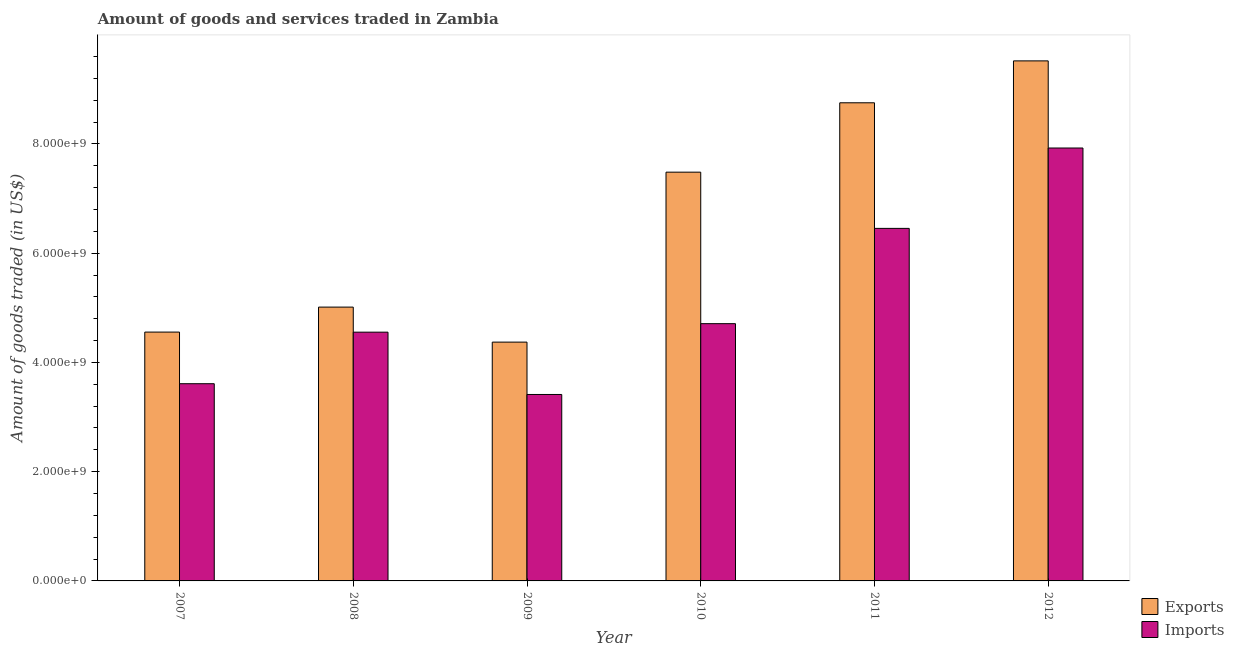How many groups of bars are there?
Make the answer very short. 6. How many bars are there on the 5th tick from the left?
Provide a short and direct response. 2. What is the label of the 4th group of bars from the left?
Your answer should be compact. 2010. In how many cases, is the number of bars for a given year not equal to the number of legend labels?
Offer a terse response. 0. What is the amount of goods exported in 2012?
Keep it short and to the point. 9.52e+09. Across all years, what is the maximum amount of goods exported?
Offer a very short reply. 9.52e+09. Across all years, what is the minimum amount of goods imported?
Your answer should be compact. 3.41e+09. In which year was the amount of goods exported maximum?
Provide a short and direct response. 2012. What is the total amount of goods imported in the graph?
Give a very brief answer. 3.07e+1. What is the difference between the amount of goods imported in 2007 and that in 2010?
Make the answer very short. -1.10e+09. What is the difference between the amount of goods exported in 2011 and the amount of goods imported in 2010?
Provide a succinct answer. 1.27e+09. What is the average amount of goods exported per year?
Your answer should be very brief. 6.62e+09. What is the ratio of the amount of goods imported in 2009 to that in 2010?
Your answer should be compact. 0.72. What is the difference between the highest and the second highest amount of goods imported?
Your response must be concise. 1.47e+09. What is the difference between the highest and the lowest amount of goods imported?
Keep it short and to the point. 4.51e+09. In how many years, is the amount of goods exported greater than the average amount of goods exported taken over all years?
Ensure brevity in your answer.  3. What does the 2nd bar from the left in 2009 represents?
Keep it short and to the point. Imports. What does the 1st bar from the right in 2010 represents?
Offer a very short reply. Imports. How many bars are there?
Keep it short and to the point. 12. Are all the bars in the graph horizontal?
Provide a short and direct response. No. Does the graph contain grids?
Your answer should be compact. No. How many legend labels are there?
Your answer should be compact. 2. What is the title of the graph?
Your response must be concise. Amount of goods and services traded in Zambia. Does "Urban" appear as one of the legend labels in the graph?
Provide a succinct answer. No. What is the label or title of the Y-axis?
Make the answer very short. Amount of goods traded (in US$). What is the Amount of goods traded (in US$) in Exports in 2007?
Ensure brevity in your answer.  4.56e+09. What is the Amount of goods traded (in US$) in Imports in 2007?
Provide a short and direct response. 3.61e+09. What is the Amount of goods traded (in US$) in Exports in 2008?
Your answer should be compact. 5.01e+09. What is the Amount of goods traded (in US$) in Imports in 2008?
Offer a terse response. 4.55e+09. What is the Amount of goods traded (in US$) of Exports in 2009?
Offer a terse response. 4.37e+09. What is the Amount of goods traded (in US$) in Imports in 2009?
Keep it short and to the point. 3.41e+09. What is the Amount of goods traded (in US$) in Exports in 2010?
Offer a terse response. 7.48e+09. What is the Amount of goods traded (in US$) in Imports in 2010?
Offer a terse response. 4.71e+09. What is the Amount of goods traded (in US$) of Exports in 2011?
Your answer should be compact. 8.75e+09. What is the Amount of goods traded (in US$) of Imports in 2011?
Provide a succinct answer. 6.45e+09. What is the Amount of goods traded (in US$) of Exports in 2012?
Give a very brief answer. 9.52e+09. What is the Amount of goods traded (in US$) in Imports in 2012?
Provide a short and direct response. 7.93e+09. Across all years, what is the maximum Amount of goods traded (in US$) in Exports?
Provide a short and direct response. 9.52e+09. Across all years, what is the maximum Amount of goods traded (in US$) of Imports?
Offer a terse response. 7.93e+09. Across all years, what is the minimum Amount of goods traded (in US$) of Exports?
Your answer should be compact. 4.37e+09. Across all years, what is the minimum Amount of goods traded (in US$) of Imports?
Your answer should be very brief. 3.41e+09. What is the total Amount of goods traded (in US$) in Exports in the graph?
Ensure brevity in your answer.  3.97e+1. What is the total Amount of goods traded (in US$) of Imports in the graph?
Offer a very short reply. 3.07e+1. What is the difference between the Amount of goods traded (in US$) of Exports in 2007 and that in 2008?
Provide a succinct answer. -4.58e+08. What is the difference between the Amount of goods traded (in US$) in Imports in 2007 and that in 2008?
Your answer should be very brief. -9.44e+08. What is the difference between the Amount of goods traded (in US$) of Exports in 2007 and that in 2009?
Keep it short and to the point. 1.84e+08. What is the difference between the Amount of goods traded (in US$) of Imports in 2007 and that in 2009?
Offer a terse response. 1.97e+08. What is the difference between the Amount of goods traded (in US$) in Exports in 2007 and that in 2010?
Provide a short and direct response. -2.93e+09. What is the difference between the Amount of goods traded (in US$) in Imports in 2007 and that in 2010?
Your answer should be compact. -1.10e+09. What is the difference between the Amount of goods traded (in US$) of Exports in 2007 and that in 2011?
Keep it short and to the point. -4.20e+09. What is the difference between the Amount of goods traded (in US$) of Imports in 2007 and that in 2011?
Your answer should be very brief. -2.84e+09. What is the difference between the Amount of goods traded (in US$) of Exports in 2007 and that in 2012?
Your response must be concise. -4.97e+09. What is the difference between the Amount of goods traded (in US$) in Imports in 2007 and that in 2012?
Offer a terse response. -4.31e+09. What is the difference between the Amount of goods traded (in US$) in Exports in 2008 and that in 2009?
Offer a terse response. 6.41e+08. What is the difference between the Amount of goods traded (in US$) in Imports in 2008 and that in 2009?
Give a very brief answer. 1.14e+09. What is the difference between the Amount of goods traded (in US$) in Exports in 2008 and that in 2010?
Make the answer very short. -2.47e+09. What is the difference between the Amount of goods traded (in US$) in Imports in 2008 and that in 2010?
Give a very brief answer. -1.56e+08. What is the difference between the Amount of goods traded (in US$) in Exports in 2008 and that in 2011?
Your answer should be very brief. -3.74e+09. What is the difference between the Amount of goods traded (in US$) of Imports in 2008 and that in 2011?
Offer a very short reply. -1.90e+09. What is the difference between the Amount of goods traded (in US$) of Exports in 2008 and that in 2012?
Your answer should be very brief. -4.51e+09. What is the difference between the Amount of goods traded (in US$) of Imports in 2008 and that in 2012?
Provide a short and direct response. -3.37e+09. What is the difference between the Amount of goods traded (in US$) in Exports in 2009 and that in 2010?
Your answer should be very brief. -3.11e+09. What is the difference between the Amount of goods traded (in US$) in Imports in 2009 and that in 2010?
Provide a succinct answer. -1.30e+09. What is the difference between the Amount of goods traded (in US$) of Exports in 2009 and that in 2011?
Offer a very short reply. -4.38e+09. What is the difference between the Amount of goods traded (in US$) of Imports in 2009 and that in 2011?
Your answer should be very brief. -3.04e+09. What is the difference between the Amount of goods traded (in US$) in Exports in 2009 and that in 2012?
Provide a short and direct response. -5.15e+09. What is the difference between the Amount of goods traded (in US$) of Imports in 2009 and that in 2012?
Offer a terse response. -4.51e+09. What is the difference between the Amount of goods traded (in US$) of Exports in 2010 and that in 2011?
Provide a short and direct response. -1.27e+09. What is the difference between the Amount of goods traded (in US$) in Imports in 2010 and that in 2011?
Your answer should be very brief. -1.74e+09. What is the difference between the Amount of goods traded (in US$) in Exports in 2010 and that in 2012?
Ensure brevity in your answer.  -2.04e+09. What is the difference between the Amount of goods traded (in US$) of Imports in 2010 and that in 2012?
Keep it short and to the point. -3.22e+09. What is the difference between the Amount of goods traded (in US$) of Exports in 2011 and that in 2012?
Offer a terse response. -7.67e+08. What is the difference between the Amount of goods traded (in US$) of Imports in 2011 and that in 2012?
Make the answer very short. -1.47e+09. What is the difference between the Amount of goods traded (in US$) in Exports in 2007 and the Amount of goods traded (in US$) in Imports in 2008?
Your answer should be very brief. 1.37e+06. What is the difference between the Amount of goods traded (in US$) of Exports in 2007 and the Amount of goods traded (in US$) of Imports in 2009?
Ensure brevity in your answer.  1.14e+09. What is the difference between the Amount of goods traded (in US$) of Exports in 2007 and the Amount of goods traded (in US$) of Imports in 2010?
Give a very brief answer. -1.54e+08. What is the difference between the Amount of goods traded (in US$) of Exports in 2007 and the Amount of goods traded (in US$) of Imports in 2011?
Provide a succinct answer. -1.90e+09. What is the difference between the Amount of goods traded (in US$) of Exports in 2007 and the Amount of goods traded (in US$) of Imports in 2012?
Your answer should be compact. -3.37e+09. What is the difference between the Amount of goods traded (in US$) of Exports in 2008 and the Amount of goods traded (in US$) of Imports in 2009?
Make the answer very short. 1.60e+09. What is the difference between the Amount of goods traded (in US$) of Exports in 2008 and the Amount of goods traded (in US$) of Imports in 2010?
Offer a terse response. 3.03e+08. What is the difference between the Amount of goods traded (in US$) of Exports in 2008 and the Amount of goods traded (in US$) of Imports in 2011?
Offer a terse response. -1.44e+09. What is the difference between the Amount of goods traded (in US$) of Exports in 2008 and the Amount of goods traded (in US$) of Imports in 2012?
Your response must be concise. -2.91e+09. What is the difference between the Amount of goods traded (in US$) of Exports in 2009 and the Amount of goods traded (in US$) of Imports in 2010?
Your response must be concise. -3.38e+08. What is the difference between the Amount of goods traded (in US$) in Exports in 2009 and the Amount of goods traded (in US$) in Imports in 2011?
Your answer should be compact. -2.08e+09. What is the difference between the Amount of goods traded (in US$) in Exports in 2009 and the Amount of goods traded (in US$) in Imports in 2012?
Give a very brief answer. -3.55e+09. What is the difference between the Amount of goods traded (in US$) in Exports in 2010 and the Amount of goods traded (in US$) in Imports in 2011?
Keep it short and to the point. 1.03e+09. What is the difference between the Amount of goods traded (in US$) of Exports in 2010 and the Amount of goods traded (in US$) of Imports in 2012?
Keep it short and to the point. -4.42e+08. What is the difference between the Amount of goods traded (in US$) of Exports in 2011 and the Amount of goods traded (in US$) of Imports in 2012?
Offer a terse response. 8.28e+08. What is the average Amount of goods traded (in US$) of Exports per year?
Offer a very short reply. 6.62e+09. What is the average Amount of goods traded (in US$) in Imports per year?
Your response must be concise. 5.11e+09. In the year 2007, what is the difference between the Amount of goods traded (in US$) in Exports and Amount of goods traded (in US$) in Imports?
Your answer should be very brief. 9.45e+08. In the year 2008, what is the difference between the Amount of goods traded (in US$) in Exports and Amount of goods traded (in US$) in Imports?
Offer a very short reply. 4.59e+08. In the year 2009, what is the difference between the Amount of goods traded (in US$) of Exports and Amount of goods traded (in US$) of Imports?
Your response must be concise. 9.59e+08. In the year 2010, what is the difference between the Amount of goods traded (in US$) of Exports and Amount of goods traded (in US$) of Imports?
Keep it short and to the point. 2.77e+09. In the year 2011, what is the difference between the Amount of goods traded (in US$) in Exports and Amount of goods traded (in US$) in Imports?
Ensure brevity in your answer.  2.30e+09. In the year 2012, what is the difference between the Amount of goods traded (in US$) of Exports and Amount of goods traded (in US$) of Imports?
Offer a very short reply. 1.60e+09. What is the ratio of the Amount of goods traded (in US$) in Exports in 2007 to that in 2008?
Provide a short and direct response. 0.91. What is the ratio of the Amount of goods traded (in US$) of Imports in 2007 to that in 2008?
Give a very brief answer. 0.79. What is the ratio of the Amount of goods traded (in US$) in Exports in 2007 to that in 2009?
Your answer should be compact. 1.04. What is the ratio of the Amount of goods traded (in US$) in Imports in 2007 to that in 2009?
Ensure brevity in your answer.  1.06. What is the ratio of the Amount of goods traded (in US$) in Exports in 2007 to that in 2010?
Make the answer very short. 0.61. What is the ratio of the Amount of goods traded (in US$) of Imports in 2007 to that in 2010?
Keep it short and to the point. 0.77. What is the ratio of the Amount of goods traded (in US$) in Exports in 2007 to that in 2011?
Your answer should be very brief. 0.52. What is the ratio of the Amount of goods traded (in US$) in Imports in 2007 to that in 2011?
Your answer should be compact. 0.56. What is the ratio of the Amount of goods traded (in US$) in Exports in 2007 to that in 2012?
Your response must be concise. 0.48. What is the ratio of the Amount of goods traded (in US$) in Imports in 2007 to that in 2012?
Ensure brevity in your answer.  0.46. What is the ratio of the Amount of goods traded (in US$) in Exports in 2008 to that in 2009?
Keep it short and to the point. 1.15. What is the ratio of the Amount of goods traded (in US$) of Imports in 2008 to that in 2009?
Ensure brevity in your answer.  1.33. What is the ratio of the Amount of goods traded (in US$) of Exports in 2008 to that in 2010?
Provide a succinct answer. 0.67. What is the ratio of the Amount of goods traded (in US$) in Imports in 2008 to that in 2010?
Your answer should be compact. 0.97. What is the ratio of the Amount of goods traded (in US$) of Exports in 2008 to that in 2011?
Offer a very short reply. 0.57. What is the ratio of the Amount of goods traded (in US$) of Imports in 2008 to that in 2011?
Give a very brief answer. 0.71. What is the ratio of the Amount of goods traded (in US$) in Exports in 2008 to that in 2012?
Make the answer very short. 0.53. What is the ratio of the Amount of goods traded (in US$) in Imports in 2008 to that in 2012?
Your answer should be compact. 0.57. What is the ratio of the Amount of goods traded (in US$) in Exports in 2009 to that in 2010?
Keep it short and to the point. 0.58. What is the ratio of the Amount of goods traded (in US$) of Imports in 2009 to that in 2010?
Provide a short and direct response. 0.72. What is the ratio of the Amount of goods traded (in US$) of Exports in 2009 to that in 2011?
Your answer should be very brief. 0.5. What is the ratio of the Amount of goods traded (in US$) in Imports in 2009 to that in 2011?
Your response must be concise. 0.53. What is the ratio of the Amount of goods traded (in US$) of Exports in 2009 to that in 2012?
Give a very brief answer. 0.46. What is the ratio of the Amount of goods traded (in US$) in Imports in 2009 to that in 2012?
Provide a short and direct response. 0.43. What is the ratio of the Amount of goods traded (in US$) of Exports in 2010 to that in 2011?
Provide a short and direct response. 0.85. What is the ratio of the Amount of goods traded (in US$) of Imports in 2010 to that in 2011?
Keep it short and to the point. 0.73. What is the ratio of the Amount of goods traded (in US$) in Exports in 2010 to that in 2012?
Ensure brevity in your answer.  0.79. What is the ratio of the Amount of goods traded (in US$) of Imports in 2010 to that in 2012?
Offer a terse response. 0.59. What is the ratio of the Amount of goods traded (in US$) in Exports in 2011 to that in 2012?
Provide a succinct answer. 0.92. What is the ratio of the Amount of goods traded (in US$) of Imports in 2011 to that in 2012?
Keep it short and to the point. 0.81. What is the difference between the highest and the second highest Amount of goods traded (in US$) in Exports?
Provide a short and direct response. 7.67e+08. What is the difference between the highest and the second highest Amount of goods traded (in US$) in Imports?
Your response must be concise. 1.47e+09. What is the difference between the highest and the lowest Amount of goods traded (in US$) of Exports?
Provide a succinct answer. 5.15e+09. What is the difference between the highest and the lowest Amount of goods traded (in US$) in Imports?
Provide a short and direct response. 4.51e+09. 